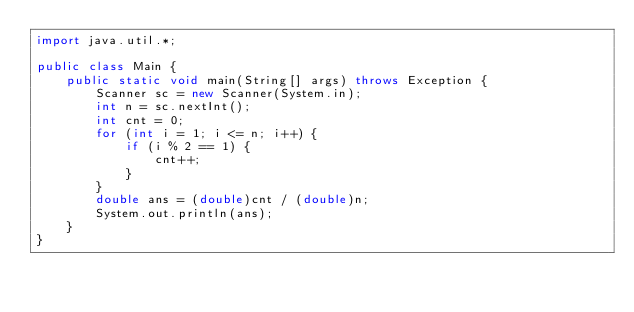<code> <loc_0><loc_0><loc_500><loc_500><_Java_>import java.util.*;

public class Main {
    public static void main(String[] args) throws Exception {
        Scanner sc = new Scanner(System.in);
        int n = sc.nextInt();
        int cnt = 0;
        for (int i = 1; i <= n; i++) {
            if (i % 2 == 1) {
                cnt++;
            }
        }
        double ans = (double)cnt / (double)n;
        System.out.println(ans);
    }
}
</code> 